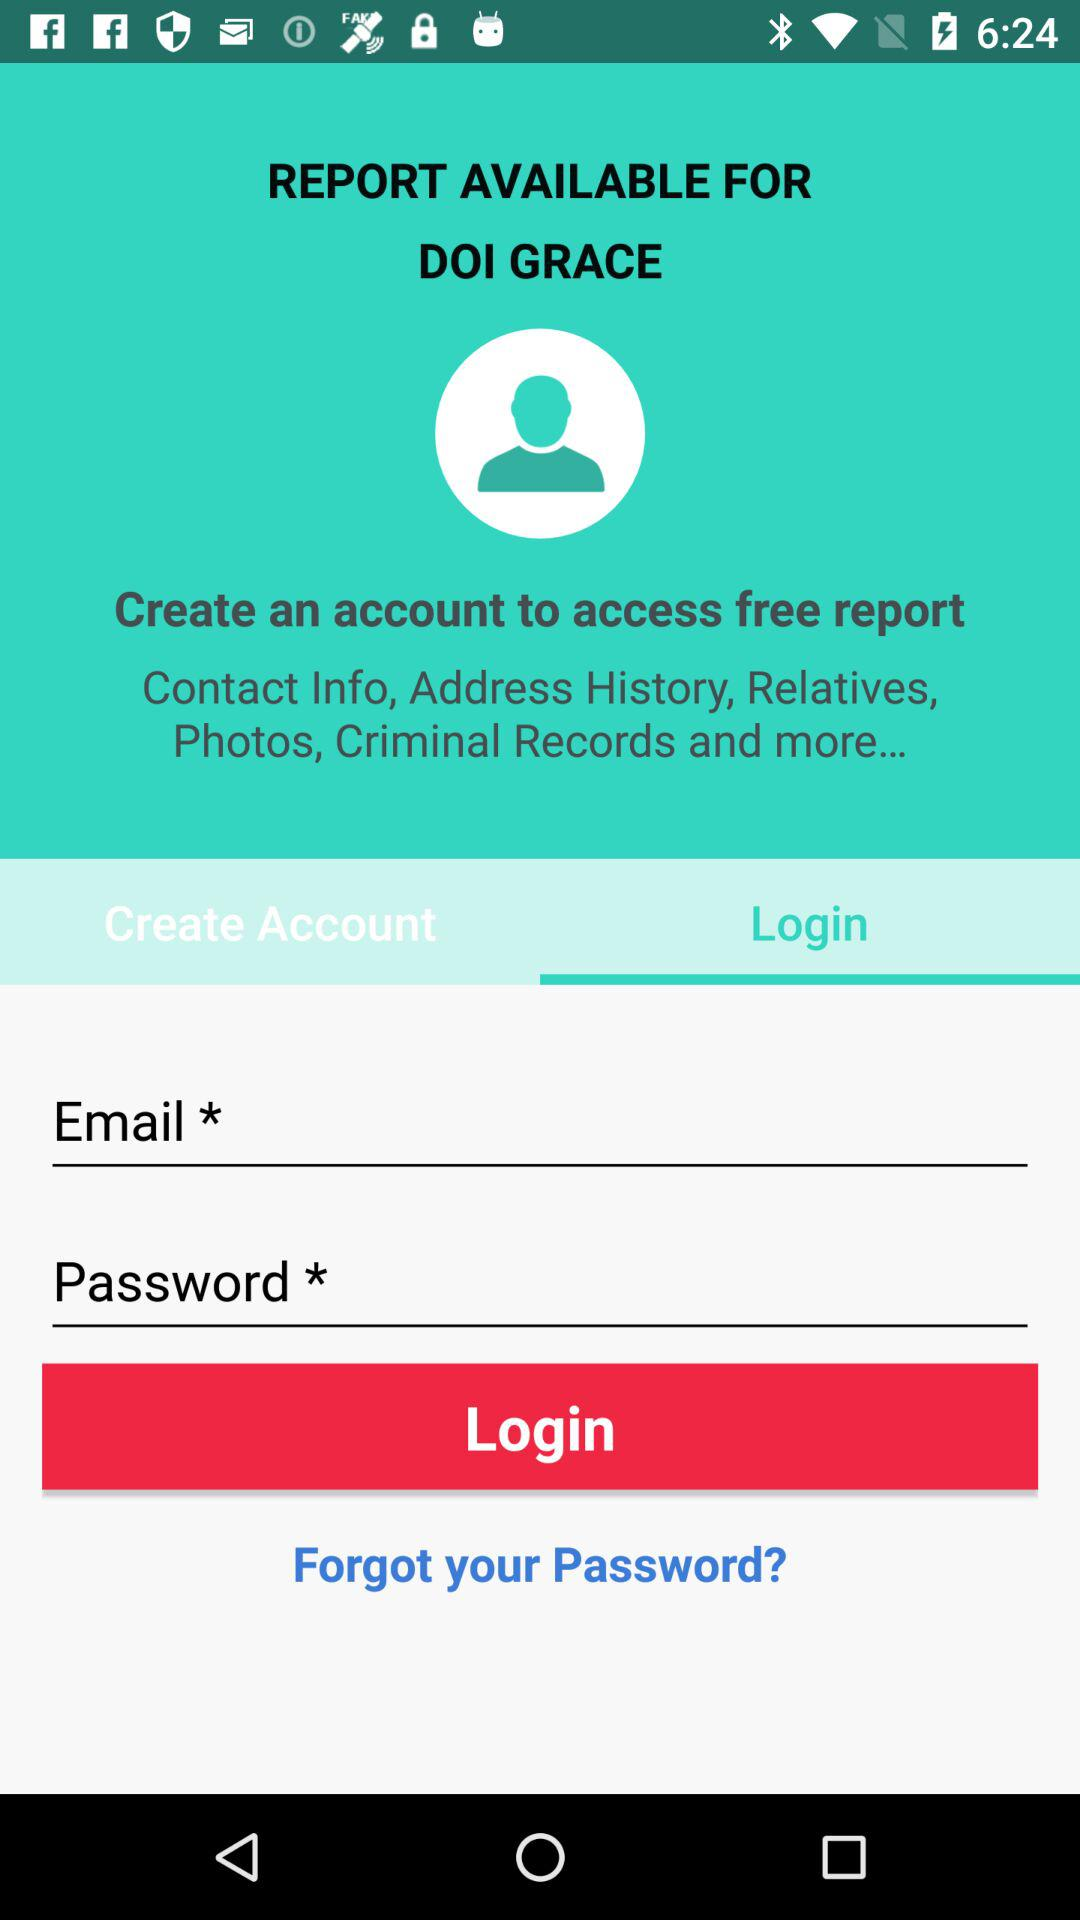Which tab is selected? The selected tab is "Login". 